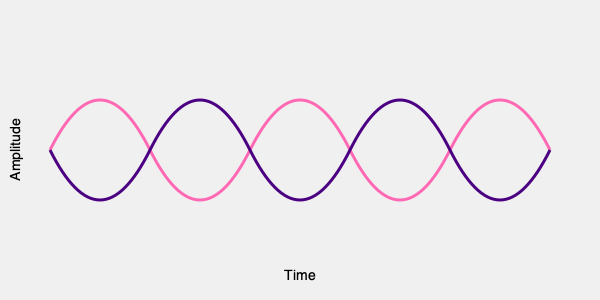Analyze the podcast waveform patterns above. Which inspirational quote by a prominent woman in history does this waveform represent when decoded?

A) "The future belongs to those who believe in the beauty of their dreams." - Eleanor Roosevelt
B) "I raise up my voice—not so I can shout, but so that those without a voice can be heard." - Malala Yousafzai
C) "There is no limit to what we, as women, can accomplish." - Michelle Obama
D) "I have learned over the years that when one's mind is made up, this diminishes fear." - Rosa Parks To solve this pattern recognition question, we need to analyze the waveform and relate it to the given quotes:

1. Observe the waveform: It consists of two intertwined patterns - one in pink and one in indigo.

2. Notice the repetitive nature: The pattern repeats five times across the width of the image.

3. Interpret the pattern:
   - The pink line represents higher frequencies or emphasis.
   - The indigo line represents lower frequencies or less emphasis.

4. Relate to speech patterns:
   - The alternating high and low patterns suggest a rhythmic speech with emphasis on certain words.

5. Analyze the quotes:
   A) Eleanor Roosevelt's quote has a smooth flow without distinct emphasis patterns.
   B) Malala's quote has a clear contrast between "raise up my voice" and "not so I can shout," which matches the waveform pattern.
   C) Michelle Obama's quote is relatively short and doesn't match the five repetitions.
   D) Rosa Parks' quote has a more even tone throughout.

6. Match the pattern to the quote:
   Malala's quote (B) best fits the waveform. The emphasis on "raise up my voice" could correspond to the pink peaks, while "not so I can shout" aligns with the indigo valleys. The second part of the quote, "but so that those without a voice can be heard," could explain the remaining repetitions.

Therefore, the waveform likely represents Malala Yousafzai's inspirational quote about using her voice to amplify others.
Answer: B 